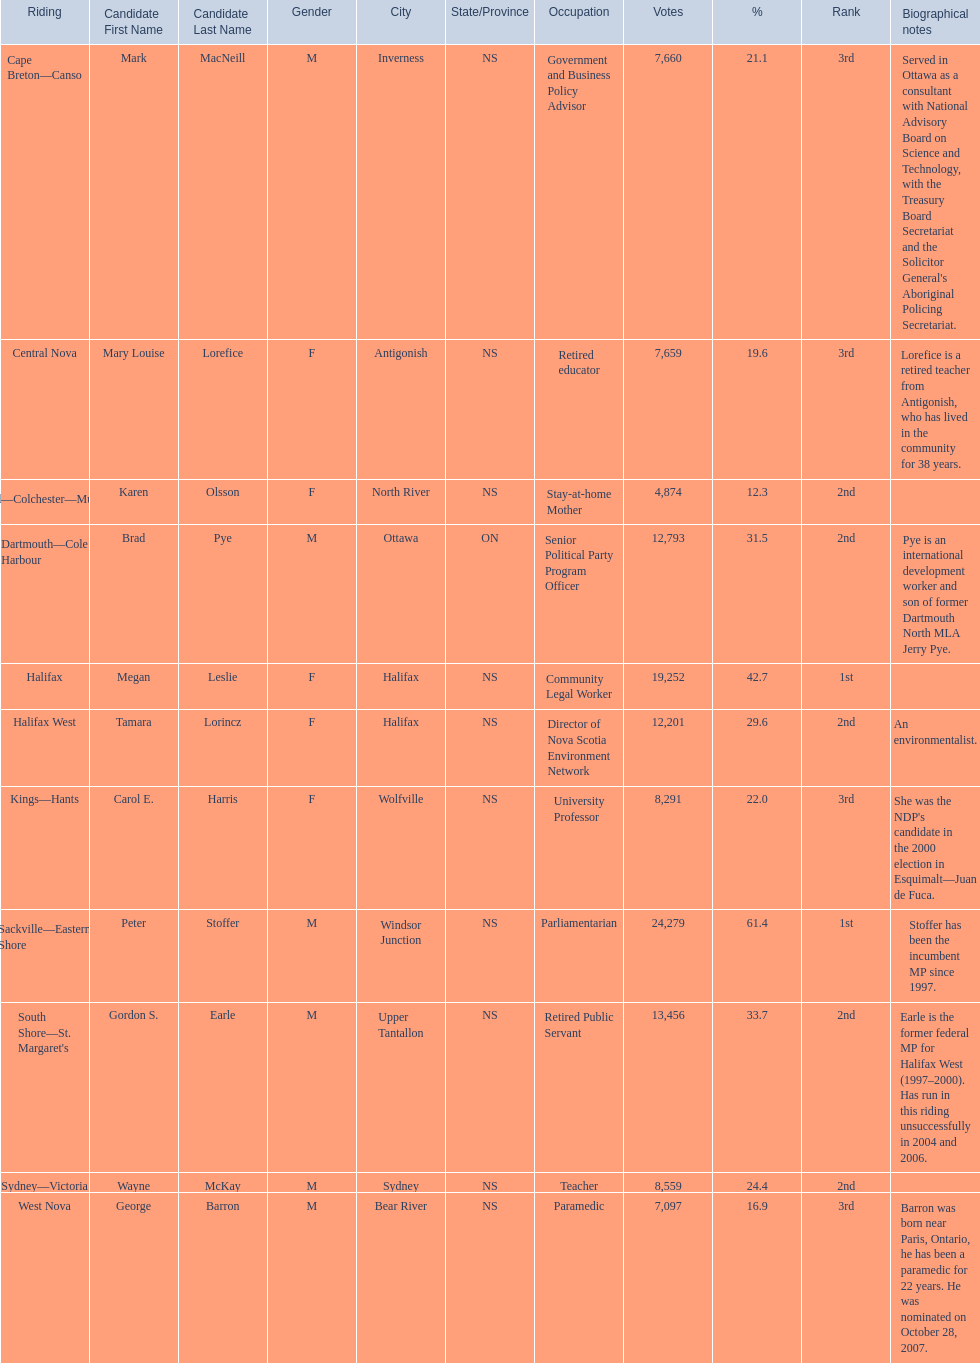Which candidates have the four lowest amount of votes Mark MacNeill, Mary Louise Lorefice, Karen Olsson, George Barron. Could you parse the entire table as a dict? {'header': ['Riding', 'Candidate First Name', 'Candidate Last Name', 'Gender', 'City', 'State/Province', 'Occupation', 'Votes', '%', 'Rank', 'Biographical notes'], 'rows': [['Cape Breton—Canso', 'Mark', 'MacNeill', 'M', 'Inverness', 'NS', 'Government and Business Policy Advisor', '7,660', '21.1', '3rd', "Served in Ottawa as a consultant with National Advisory Board on Science and Technology, with the Treasury Board Secretariat and the Solicitor General's Aboriginal Policing Secretariat."], ['Central Nova', 'Mary Louise', 'Lorefice', 'F', 'Antigonish', 'NS', 'Retired educator', '7,659', '19.6', '3rd', 'Lorefice is a retired teacher from Antigonish, who has lived in the community for 38 years.'], ['Cumberland—Colchester—Musquodoboit Valley', 'Karen', 'Olsson', 'F', 'North River', 'NS', 'Stay-at-home Mother', '4,874', '12.3', '2nd', ''], ['Dartmouth—Cole Harbour', 'Brad', 'Pye', 'M', 'Ottawa', 'ON', 'Senior Political Party Program Officer', '12,793', '31.5', '2nd', 'Pye is an international development worker and son of former Dartmouth North MLA Jerry Pye.'], ['Halifax', 'Megan', 'Leslie', 'F', 'Halifax', 'NS', 'Community Legal Worker', '19,252', '42.7', '1st', ''], ['Halifax West', 'Tamara', 'Lorincz', 'F', 'Halifax', 'NS', 'Director of Nova Scotia Environment Network', '12,201', '29.6', '2nd', 'An environmentalist.'], ['Kings—Hants', 'Carol E.', 'Harris', 'F', 'Wolfville', 'NS', 'University Professor', '8,291', '22.0', '3rd', "She was the NDP's candidate in the 2000 election in Esquimalt—Juan de Fuca."], ['Sackville—Eastern Shore', 'Peter', 'Stoffer', 'M', 'Windsor Junction', 'NS', 'Parliamentarian', '24,279', '61.4', '1st', 'Stoffer has been the incumbent MP since 1997.'], ["South Shore—St. Margaret's", 'Gordon S.', 'Earle', 'M', 'Upper Tantallon', 'NS', 'Retired Public Servant', '13,456', '33.7', '2nd', 'Earle is the former federal MP for Halifax West (1997–2000). Has run in this riding unsuccessfully in 2004 and 2006.'], ['Sydney—Victoria', 'Wayne', 'McKay', 'M', 'Sydney', 'NS', 'Teacher', '8,559', '24.4', '2nd', ''], ['West Nova', 'George', 'Barron', 'M', 'Bear River', 'NS', 'Paramedic', '7,097', '16.9', '3rd', 'Barron was born near Paris, Ontario, he has been a paramedic for 22 years. He was nominated on October 28, 2007.']]} Out of the following, who has the third most? Mark MacNeill. 